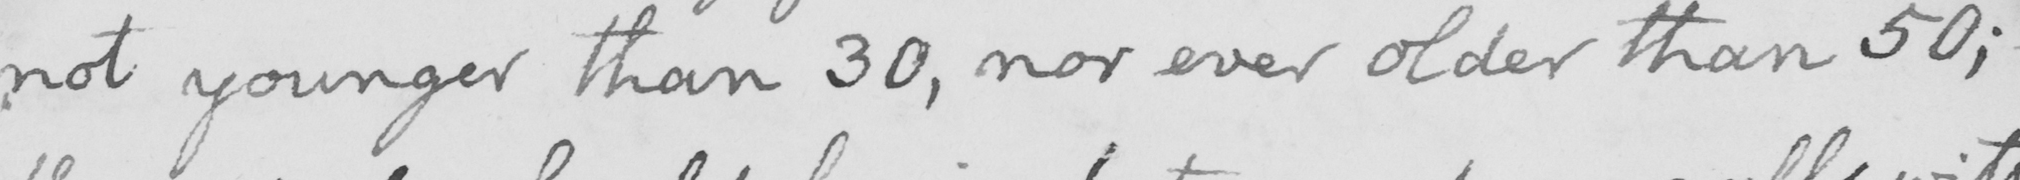Can you read and transcribe this handwriting? not younger than 30 , nor ever older than 50 ;  _ 